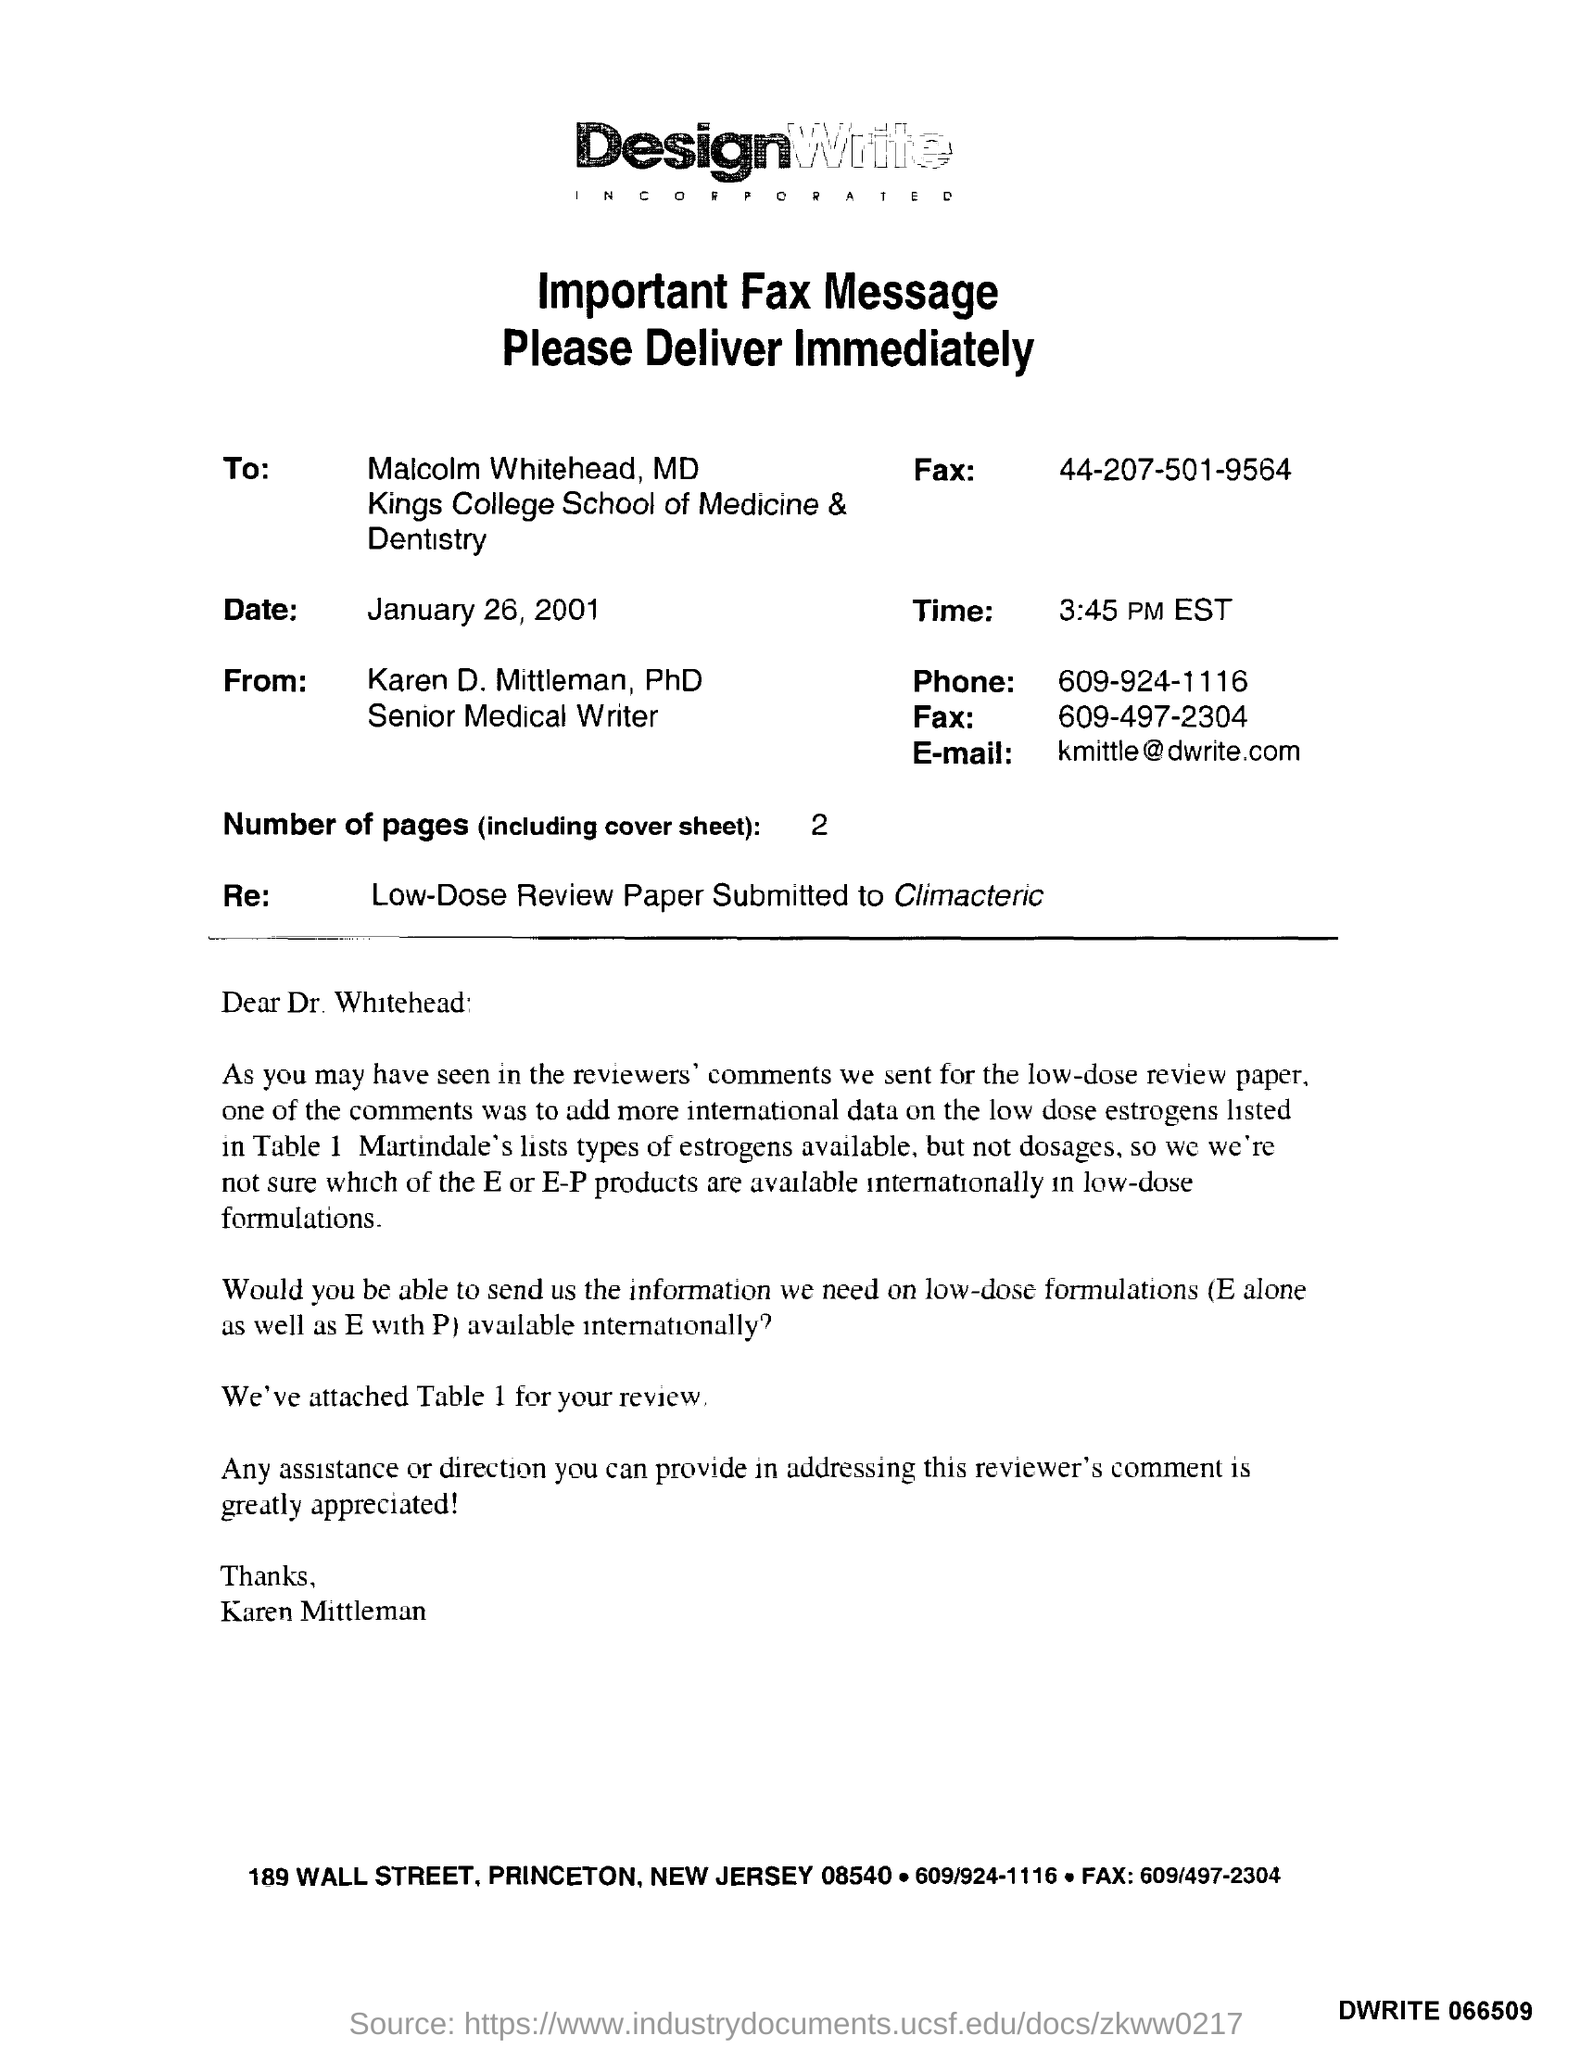What is the date mentioned in the fax message ?
Your answer should be compact. January 26, 2001. To whom this fax was sent ?
Keep it short and to the point. Malcolm whitehead. From whom this fax message was delivered ?
Provide a short and direct response. Karen d. mittleman. What is the time mentioned in the given fax message ?
Ensure brevity in your answer.  3:45 pm est. How many number of pages are there (including cover sheet )?
Offer a very short reply. 2. What is the phone number mentioned in the fax ?
Provide a short and direct response. 609-924-1116. 